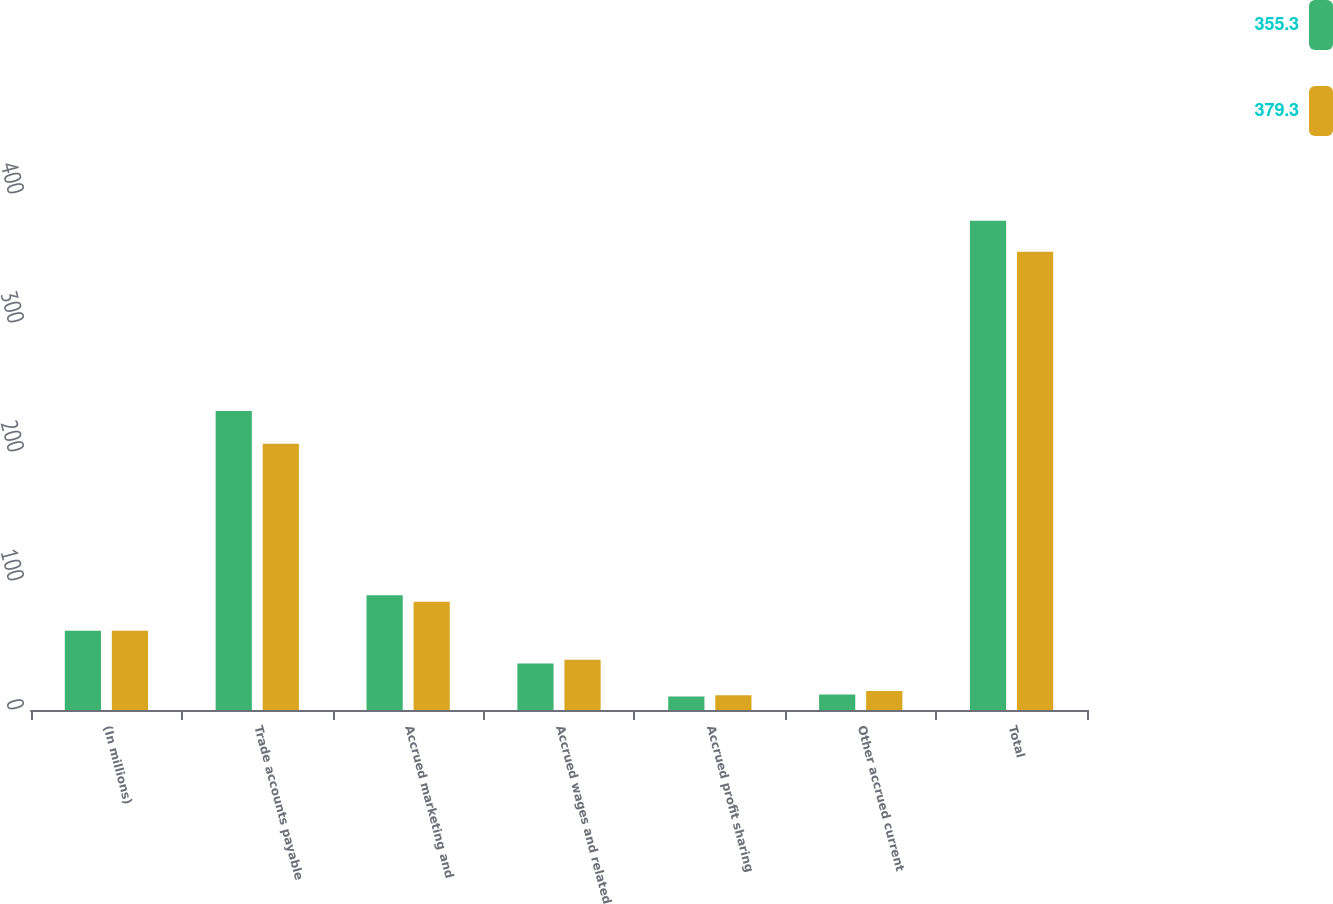<chart> <loc_0><loc_0><loc_500><loc_500><stacked_bar_chart><ecel><fcel>(In millions)<fcel>Trade accounts payable<fcel>Accrued marketing and<fcel>Accrued wages and related<fcel>Accrued profit sharing<fcel>Other accrued current<fcel>Total<nl><fcel>355.3<fcel>61.4<fcel>231.8<fcel>89<fcel>36<fcel>10.5<fcel>12<fcel>379.3<nl><fcel>379.3<fcel>61.4<fcel>206.3<fcel>83.9<fcel>38.9<fcel>11.5<fcel>14.7<fcel>355.3<nl></chart> 